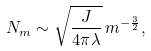<formula> <loc_0><loc_0><loc_500><loc_500>N _ { m } \sim \sqrt { \frac { J } { 4 \pi \lambda } } \, m ^ { - \frac { 3 } { 2 } } ,</formula> 